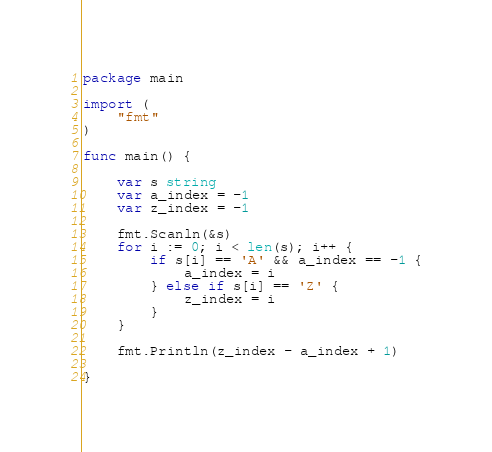<code> <loc_0><loc_0><loc_500><loc_500><_Go_>package main

import (
	"fmt"
)

func main() {

	var s string
	var a_index = -1
	var z_index = -1

	fmt.Scanln(&s)
	for i := 0; i < len(s); i++ {
		if s[i] == 'A' && a_index == -1 {
			a_index = i
		} else if s[i] == 'Z' {
			z_index = i
		}
	}

	fmt.Println(z_index - a_index + 1)

}</code> 